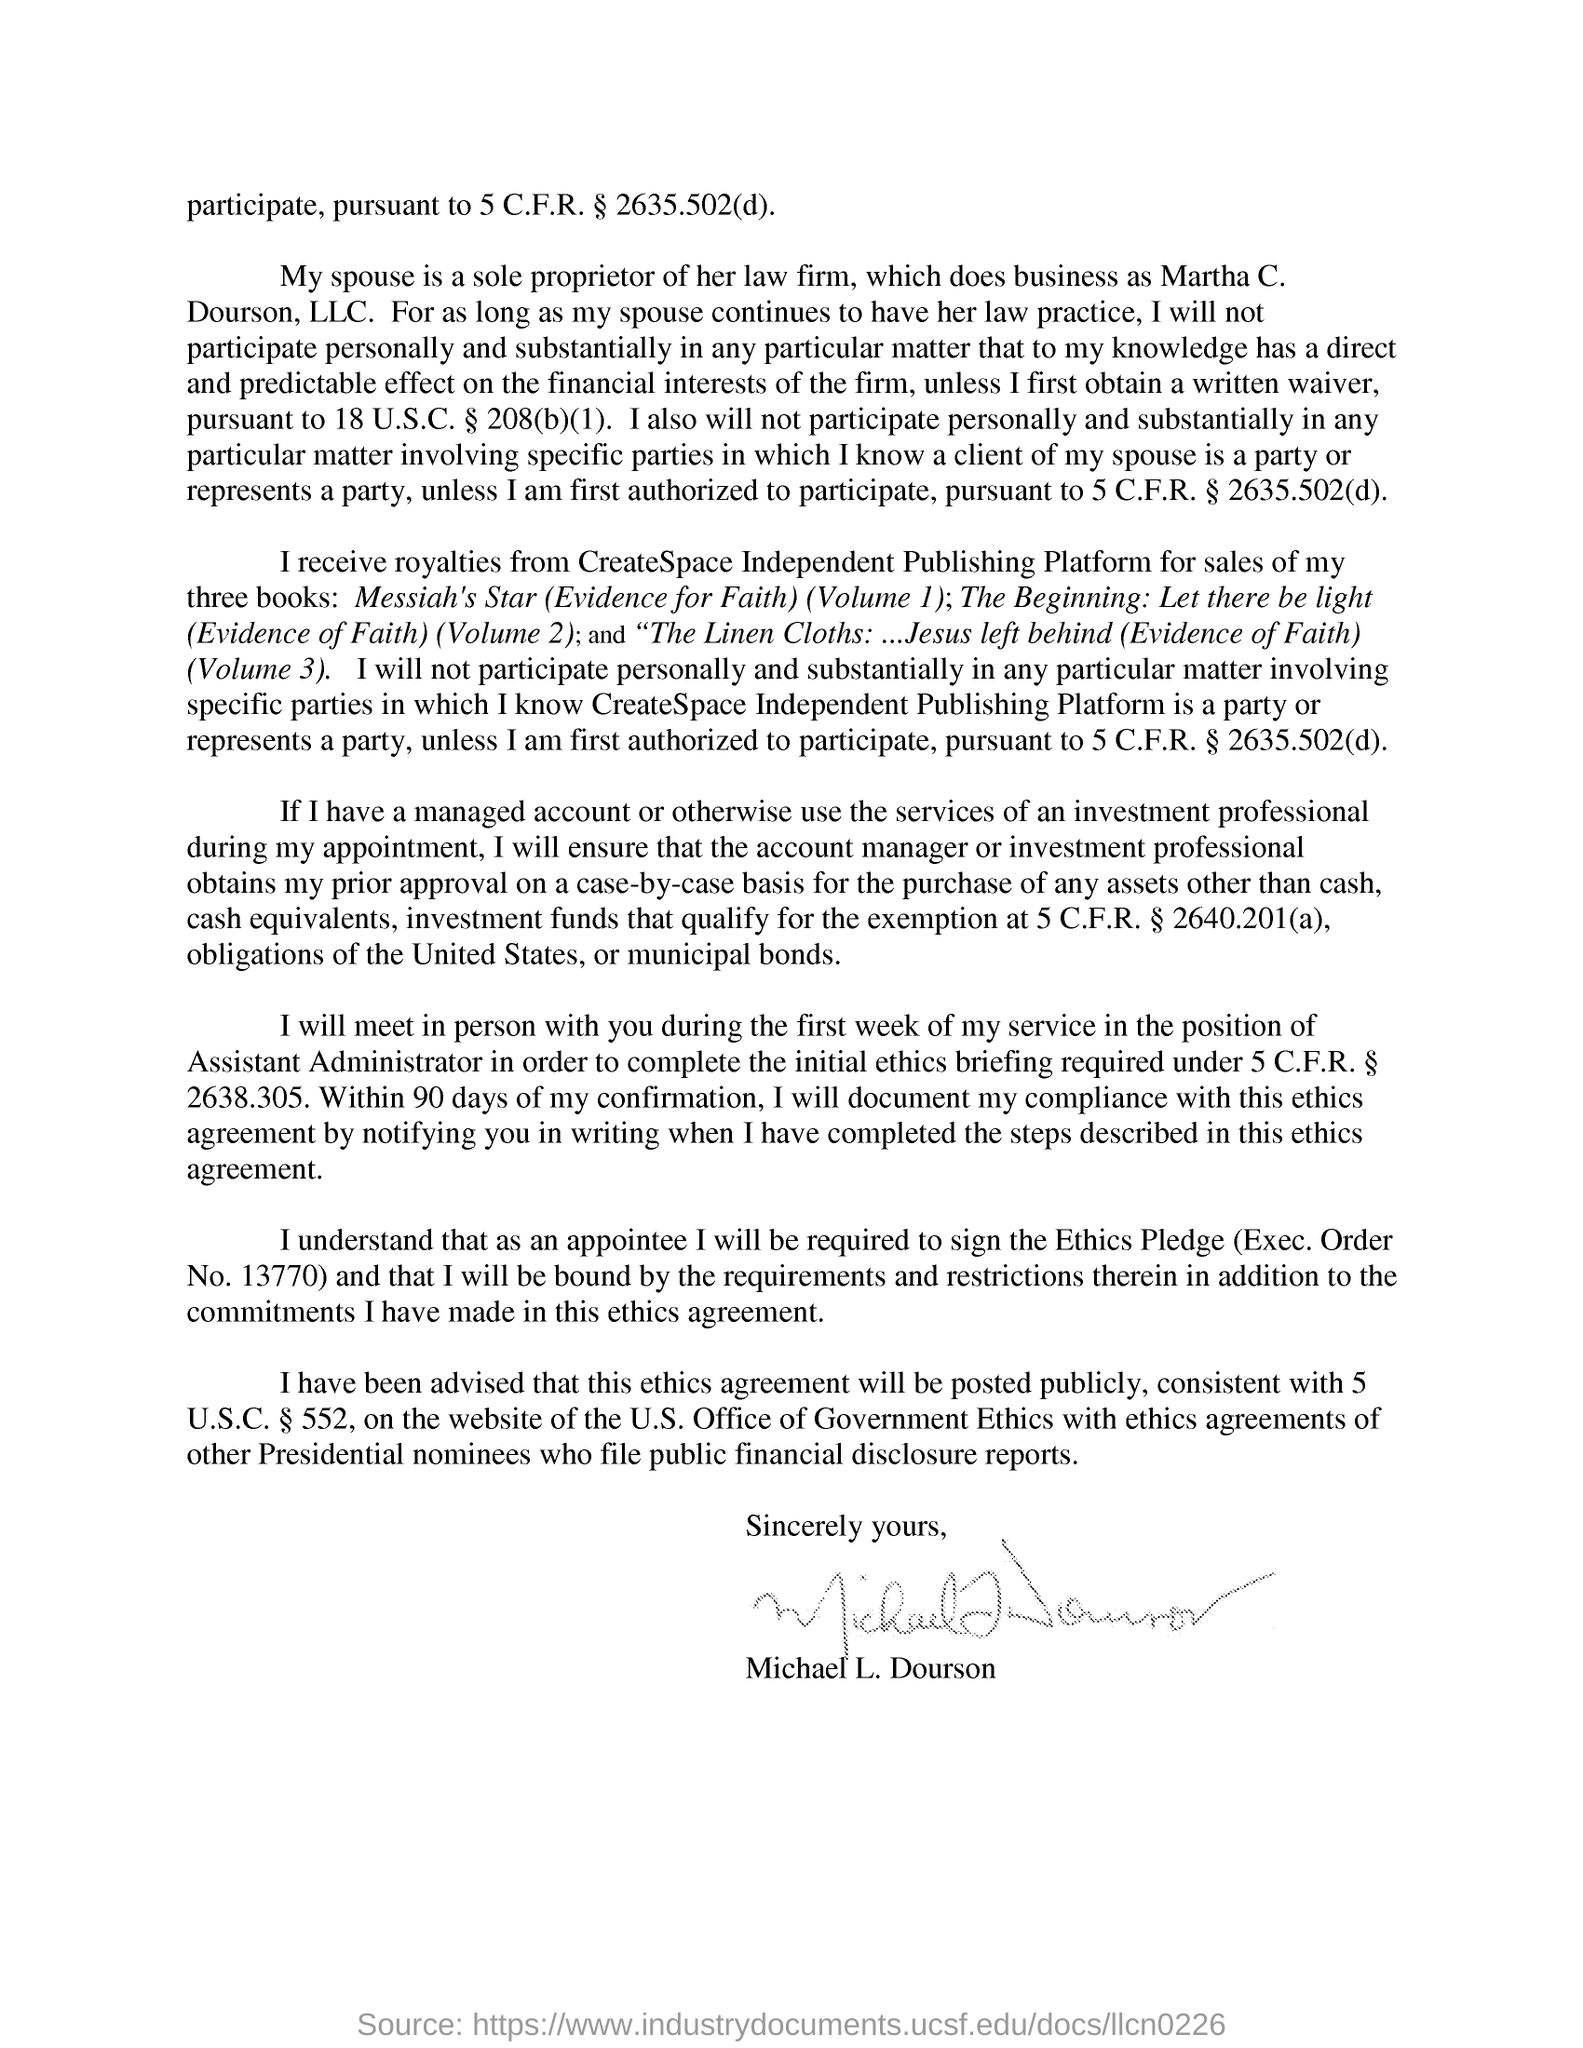Specify some key components in this picture. This ethics agreement is written by Michael L. Dourson. The author received royalties for the sales of his three books from CreateSpace Independent Publishing Platform. The author's wife is the sole proprietor of a law firm. The first book written by the author is "Messiah's Star (Evidence for Faith) (Volume 1). 